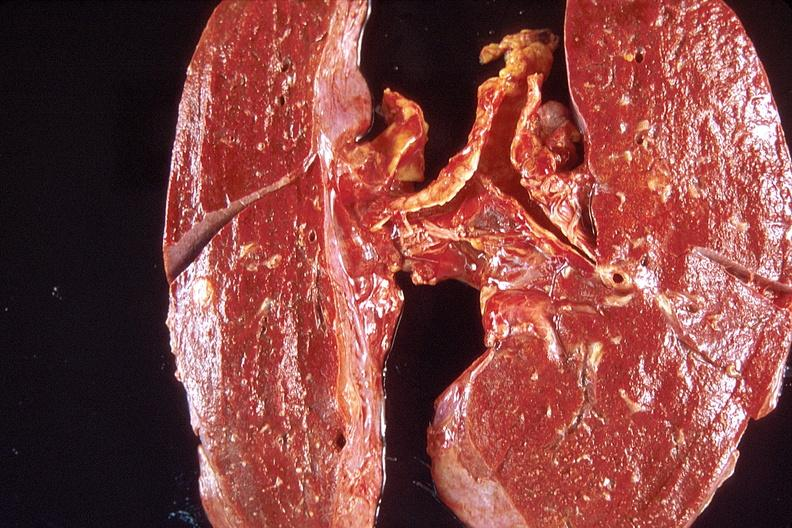s cytomegalovirus present?
Answer the question using a single word or phrase. No 